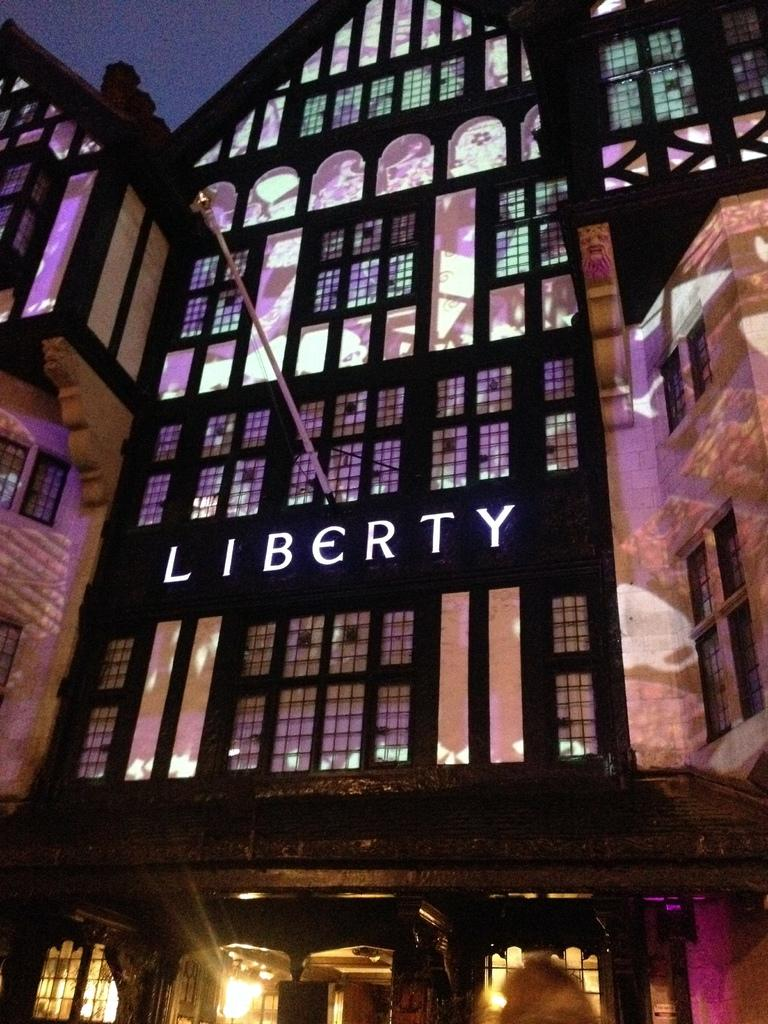What type of structure is visible in the image? There is a building in the image. What can be seen on the building? The building has some text on it. What architectural features are present in the building? There are windows and doors in the building. What else can be seen in the image besides the building? There are lights and a pole in the image. How many brothers are playing chess in the image? There are no brothers or chess game present in the image. What time of day is depicted in the image? The time of day cannot be determined from the image, as there are no specific time indicators present. 